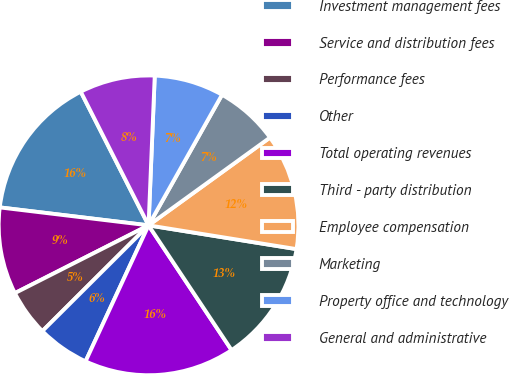Convert chart. <chart><loc_0><loc_0><loc_500><loc_500><pie_chart><fcel>Investment management fees<fcel>Service and distribution fees<fcel>Performance fees<fcel>Other<fcel>Total operating revenues<fcel>Third - party distribution<fcel>Employee compensation<fcel>Marketing<fcel>Property office and technology<fcel>General and administrative<nl><fcel>15.62%<fcel>9.38%<fcel>5.0%<fcel>5.63%<fcel>16.25%<fcel>13.12%<fcel>12.5%<fcel>6.88%<fcel>7.5%<fcel>8.13%<nl></chart> 